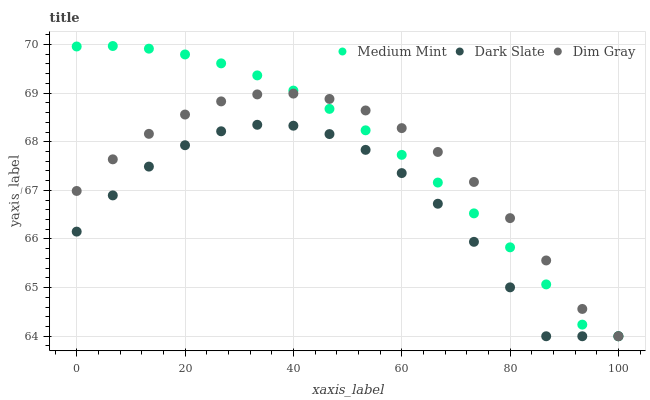Does Dark Slate have the minimum area under the curve?
Answer yes or no. Yes. Does Medium Mint have the maximum area under the curve?
Answer yes or no. Yes. Does Dim Gray have the minimum area under the curve?
Answer yes or no. No. Does Dim Gray have the maximum area under the curve?
Answer yes or no. No. Is Medium Mint the smoothest?
Answer yes or no. Yes. Is Dark Slate the roughest?
Answer yes or no. Yes. Is Dim Gray the smoothest?
Answer yes or no. No. Is Dim Gray the roughest?
Answer yes or no. No. Does Medium Mint have the lowest value?
Answer yes or no. Yes. Does Medium Mint have the highest value?
Answer yes or no. Yes. Does Dim Gray have the highest value?
Answer yes or no. No. Does Medium Mint intersect Dark Slate?
Answer yes or no. Yes. Is Medium Mint less than Dark Slate?
Answer yes or no. No. Is Medium Mint greater than Dark Slate?
Answer yes or no. No. 